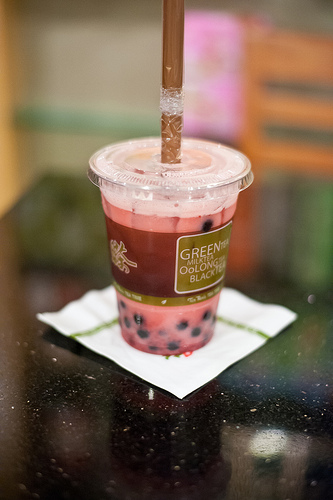<image>
Is the straw in the cup? Yes. The straw is contained within or inside the cup, showing a containment relationship. Is the cup in the table? No. The cup is not contained within the table. These objects have a different spatial relationship. 